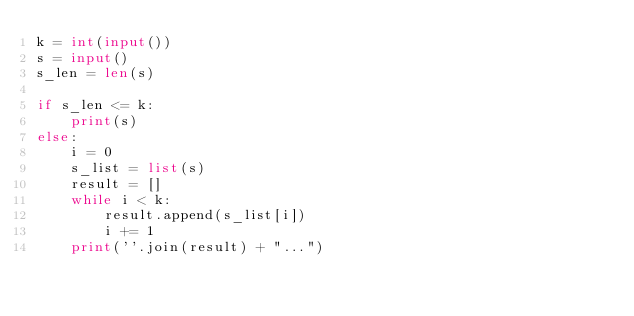Convert code to text. <code><loc_0><loc_0><loc_500><loc_500><_Python_>k = int(input())
s = input()
s_len = len(s)

if s_len <= k:
    print(s)
else:
    i = 0
    s_list = list(s)
    result = []
    while i < k:
        result.append(s_list[i])
        i += 1
    print(''.join(result) + "...")
</code> 